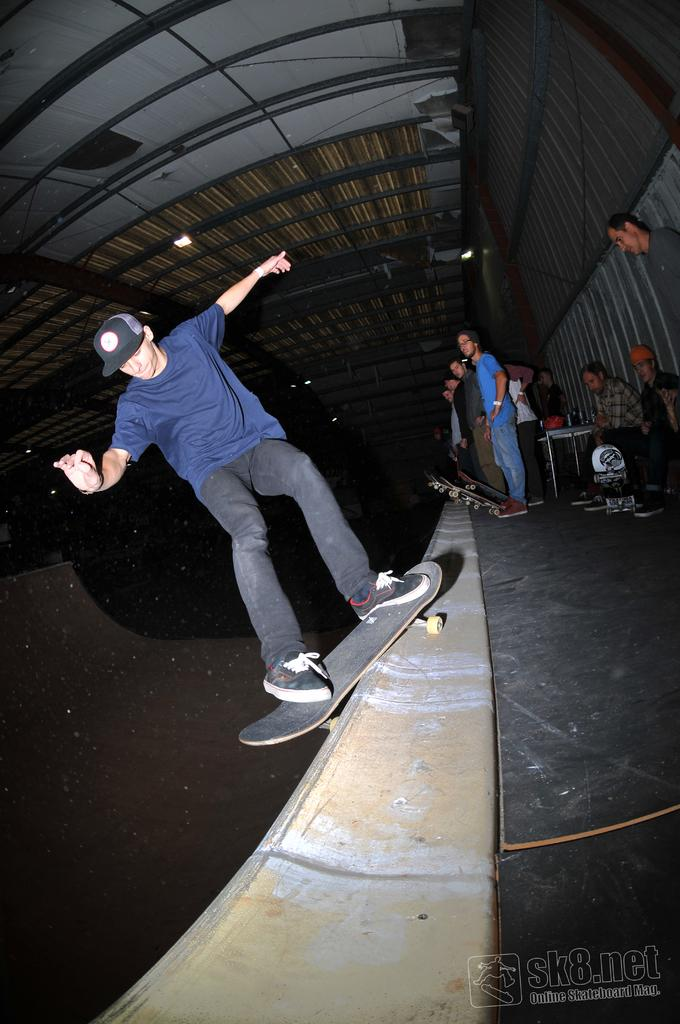What is the main activity being performed by the person in the image? The person is riding a skateboard in the image. What is the surface on which the person is riding the skateboard? The person is on a surface, but the specific type of surface is not mentioned in the facts. How many people are present in the image? There are people in the image, but the exact number is not specified. What are two of the people doing in the image? Two of the people are sitting. What type of furniture is present in the image? There is a table in the image. What can be seen in the background of the image? There are lights and a roof visible in the background of the image. What type of tomatoes are being served in a can in the image? There is no mention of tomatoes, a can, or any food items in the image. 